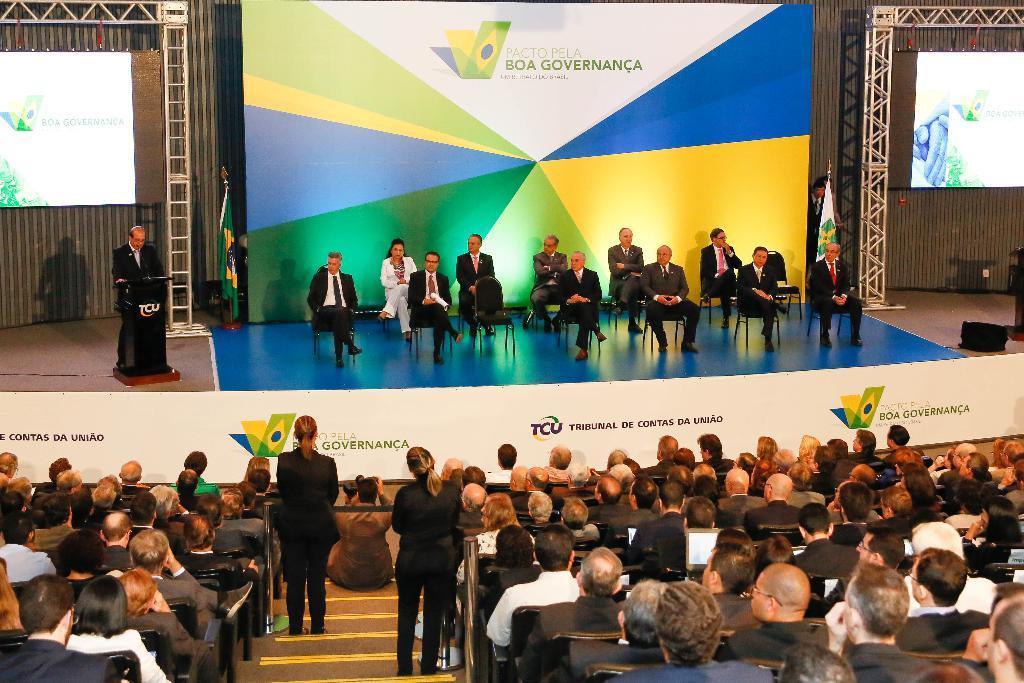Describe this image in one or two sentences. In the picture I can see people, among them some are standing and others are sitting on chairs. I can also see a podium on the stage, projector screens, boards which has something written on them and some other things. 